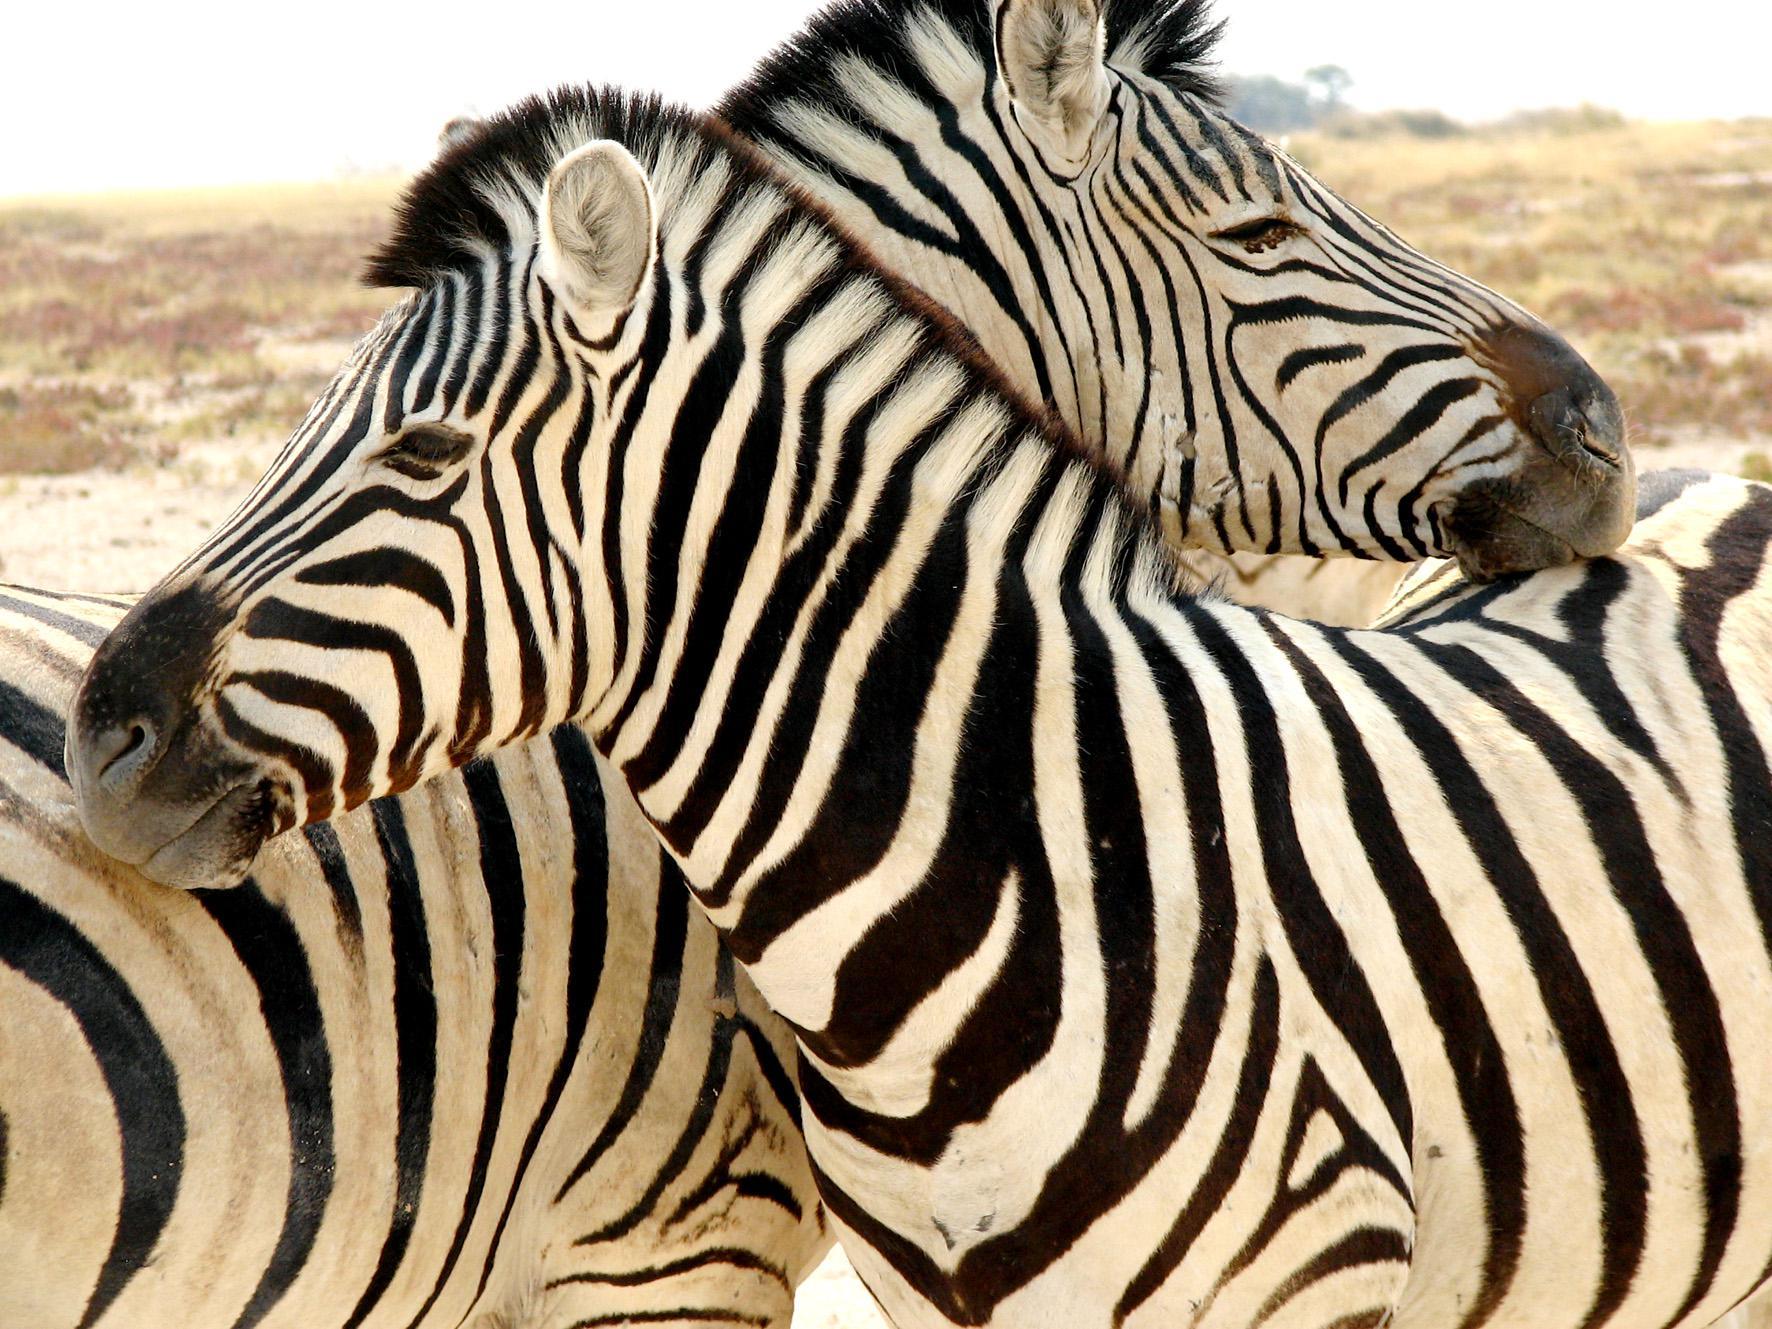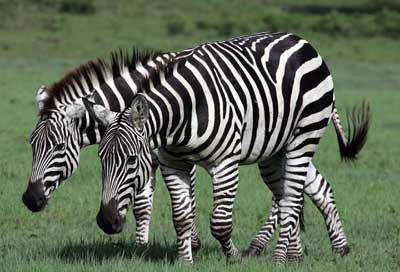The first image is the image on the left, the second image is the image on the right. Analyze the images presented: Is the assertion "One zebra is facing right." valid? Answer yes or no. Yes. 